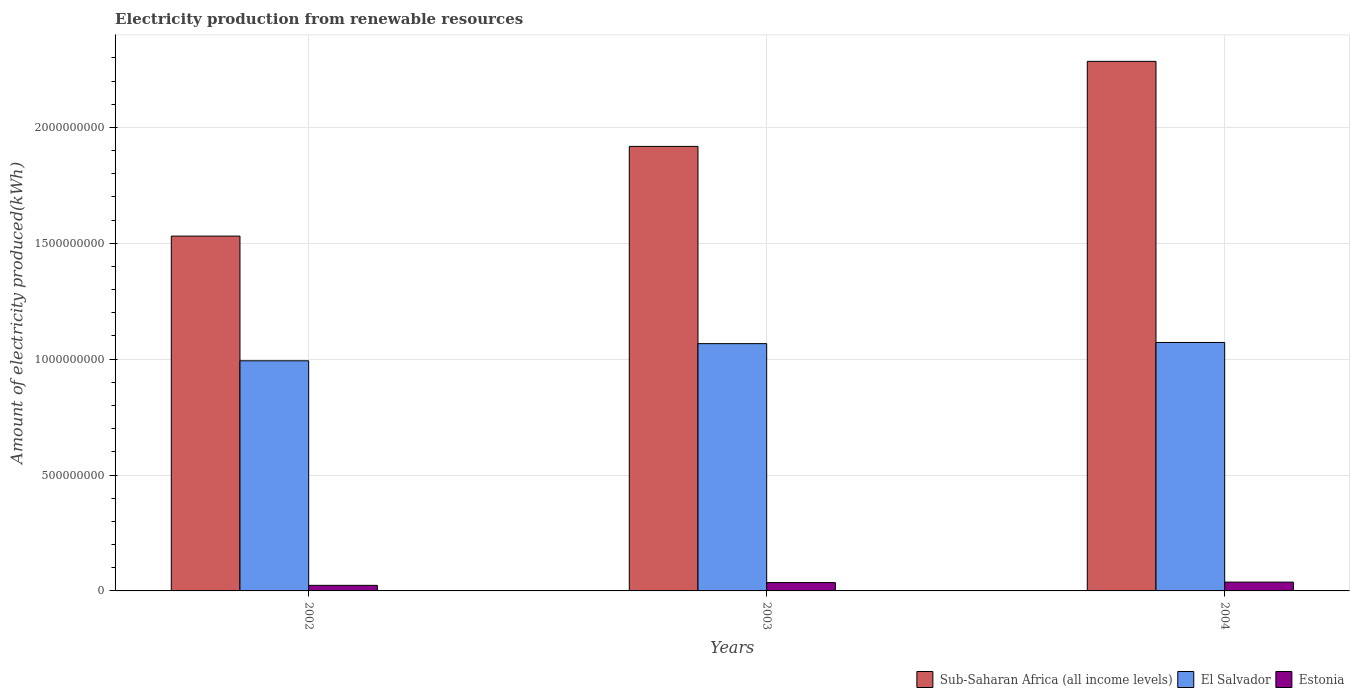How many different coloured bars are there?
Your answer should be compact. 3. Are the number of bars on each tick of the X-axis equal?
Your response must be concise. Yes. How many bars are there on the 1st tick from the right?
Your answer should be compact. 3. In how many cases, is the number of bars for a given year not equal to the number of legend labels?
Offer a terse response. 0. What is the amount of electricity produced in Sub-Saharan Africa (all income levels) in 2002?
Make the answer very short. 1.53e+09. Across all years, what is the maximum amount of electricity produced in Estonia?
Offer a terse response. 3.80e+07. Across all years, what is the minimum amount of electricity produced in Sub-Saharan Africa (all income levels)?
Your response must be concise. 1.53e+09. In which year was the amount of electricity produced in Estonia maximum?
Your response must be concise. 2004. What is the total amount of electricity produced in Sub-Saharan Africa (all income levels) in the graph?
Give a very brief answer. 5.73e+09. What is the difference between the amount of electricity produced in Sub-Saharan Africa (all income levels) in 2003 and that in 2004?
Keep it short and to the point. -3.67e+08. What is the difference between the amount of electricity produced in Sub-Saharan Africa (all income levels) in 2003 and the amount of electricity produced in Estonia in 2002?
Your response must be concise. 1.89e+09. What is the average amount of electricity produced in Sub-Saharan Africa (all income levels) per year?
Your answer should be compact. 1.91e+09. In the year 2003, what is the difference between the amount of electricity produced in El Salvador and amount of electricity produced in Sub-Saharan Africa (all income levels)?
Offer a very short reply. -8.51e+08. In how many years, is the amount of electricity produced in Estonia greater than 2200000000 kWh?
Make the answer very short. 0. What is the ratio of the amount of electricity produced in Estonia in 2003 to that in 2004?
Your answer should be compact. 0.95. Is the amount of electricity produced in Sub-Saharan Africa (all income levels) in 2002 less than that in 2004?
Ensure brevity in your answer.  Yes. Is the difference between the amount of electricity produced in El Salvador in 2003 and 2004 greater than the difference between the amount of electricity produced in Sub-Saharan Africa (all income levels) in 2003 and 2004?
Make the answer very short. Yes. What is the difference between the highest and the second highest amount of electricity produced in El Salvador?
Give a very brief answer. 5.00e+06. What is the difference between the highest and the lowest amount of electricity produced in Sub-Saharan Africa (all income levels)?
Offer a terse response. 7.54e+08. In how many years, is the amount of electricity produced in Sub-Saharan Africa (all income levels) greater than the average amount of electricity produced in Sub-Saharan Africa (all income levels) taken over all years?
Your answer should be very brief. 2. Is the sum of the amount of electricity produced in Estonia in 2003 and 2004 greater than the maximum amount of electricity produced in El Salvador across all years?
Make the answer very short. No. What does the 3rd bar from the left in 2002 represents?
Make the answer very short. Estonia. What does the 3rd bar from the right in 2002 represents?
Provide a short and direct response. Sub-Saharan Africa (all income levels). Is it the case that in every year, the sum of the amount of electricity produced in El Salvador and amount of electricity produced in Estonia is greater than the amount of electricity produced in Sub-Saharan Africa (all income levels)?
Provide a short and direct response. No. How many years are there in the graph?
Keep it short and to the point. 3. What is the difference between two consecutive major ticks on the Y-axis?
Provide a short and direct response. 5.00e+08. Are the values on the major ticks of Y-axis written in scientific E-notation?
Provide a short and direct response. No. Does the graph contain any zero values?
Ensure brevity in your answer.  No. What is the title of the graph?
Provide a succinct answer. Electricity production from renewable resources. Does "Barbados" appear as one of the legend labels in the graph?
Keep it short and to the point. No. What is the label or title of the X-axis?
Provide a succinct answer. Years. What is the label or title of the Y-axis?
Give a very brief answer. Amount of electricity produced(kWh). What is the Amount of electricity produced(kWh) in Sub-Saharan Africa (all income levels) in 2002?
Make the answer very short. 1.53e+09. What is the Amount of electricity produced(kWh) in El Salvador in 2002?
Provide a succinct answer. 9.93e+08. What is the Amount of electricity produced(kWh) in Estonia in 2002?
Your answer should be very brief. 2.40e+07. What is the Amount of electricity produced(kWh) in Sub-Saharan Africa (all income levels) in 2003?
Offer a terse response. 1.92e+09. What is the Amount of electricity produced(kWh) in El Salvador in 2003?
Offer a terse response. 1.07e+09. What is the Amount of electricity produced(kWh) in Estonia in 2003?
Your answer should be very brief. 3.60e+07. What is the Amount of electricity produced(kWh) of Sub-Saharan Africa (all income levels) in 2004?
Provide a succinct answer. 2.28e+09. What is the Amount of electricity produced(kWh) in El Salvador in 2004?
Provide a short and direct response. 1.07e+09. What is the Amount of electricity produced(kWh) in Estonia in 2004?
Your response must be concise. 3.80e+07. Across all years, what is the maximum Amount of electricity produced(kWh) of Sub-Saharan Africa (all income levels)?
Keep it short and to the point. 2.28e+09. Across all years, what is the maximum Amount of electricity produced(kWh) of El Salvador?
Keep it short and to the point. 1.07e+09. Across all years, what is the maximum Amount of electricity produced(kWh) in Estonia?
Provide a succinct answer. 3.80e+07. Across all years, what is the minimum Amount of electricity produced(kWh) in Sub-Saharan Africa (all income levels)?
Your response must be concise. 1.53e+09. Across all years, what is the minimum Amount of electricity produced(kWh) in El Salvador?
Give a very brief answer. 9.93e+08. Across all years, what is the minimum Amount of electricity produced(kWh) in Estonia?
Your answer should be compact. 2.40e+07. What is the total Amount of electricity produced(kWh) in Sub-Saharan Africa (all income levels) in the graph?
Give a very brief answer. 5.73e+09. What is the total Amount of electricity produced(kWh) of El Salvador in the graph?
Make the answer very short. 3.13e+09. What is the total Amount of electricity produced(kWh) in Estonia in the graph?
Your answer should be very brief. 9.80e+07. What is the difference between the Amount of electricity produced(kWh) of Sub-Saharan Africa (all income levels) in 2002 and that in 2003?
Keep it short and to the point. -3.87e+08. What is the difference between the Amount of electricity produced(kWh) of El Salvador in 2002 and that in 2003?
Offer a very short reply. -7.40e+07. What is the difference between the Amount of electricity produced(kWh) of Estonia in 2002 and that in 2003?
Your answer should be compact. -1.20e+07. What is the difference between the Amount of electricity produced(kWh) of Sub-Saharan Africa (all income levels) in 2002 and that in 2004?
Provide a succinct answer. -7.54e+08. What is the difference between the Amount of electricity produced(kWh) in El Salvador in 2002 and that in 2004?
Offer a terse response. -7.90e+07. What is the difference between the Amount of electricity produced(kWh) in Estonia in 2002 and that in 2004?
Your answer should be very brief. -1.40e+07. What is the difference between the Amount of electricity produced(kWh) of Sub-Saharan Africa (all income levels) in 2003 and that in 2004?
Provide a succinct answer. -3.67e+08. What is the difference between the Amount of electricity produced(kWh) of El Salvador in 2003 and that in 2004?
Offer a terse response. -5.00e+06. What is the difference between the Amount of electricity produced(kWh) in Sub-Saharan Africa (all income levels) in 2002 and the Amount of electricity produced(kWh) in El Salvador in 2003?
Your response must be concise. 4.64e+08. What is the difference between the Amount of electricity produced(kWh) of Sub-Saharan Africa (all income levels) in 2002 and the Amount of electricity produced(kWh) of Estonia in 2003?
Give a very brief answer. 1.50e+09. What is the difference between the Amount of electricity produced(kWh) of El Salvador in 2002 and the Amount of electricity produced(kWh) of Estonia in 2003?
Your answer should be compact. 9.57e+08. What is the difference between the Amount of electricity produced(kWh) of Sub-Saharan Africa (all income levels) in 2002 and the Amount of electricity produced(kWh) of El Salvador in 2004?
Make the answer very short. 4.59e+08. What is the difference between the Amount of electricity produced(kWh) of Sub-Saharan Africa (all income levels) in 2002 and the Amount of electricity produced(kWh) of Estonia in 2004?
Keep it short and to the point. 1.49e+09. What is the difference between the Amount of electricity produced(kWh) in El Salvador in 2002 and the Amount of electricity produced(kWh) in Estonia in 2004?
Offer a terse response. 9.55e+08. What is the difference between the Amount of electricity produced(kWh) of Sub-Saharan Africa (all income levels) in 2003 and the Amount of electricity produced(kWh) of El Salvador in 2004?
Provide a short and direct response. 8.46e+08. What is the difference between the Amount of electricity produced(kWh) of Sub-Saharan Africa (all income levels) in 2003 and the Amount of electricity produced(kWh) of Estonia in 2004?
Your answer should be very brief. 1.88e+09. What is the difference between the Amount of electricity produced(kWh) of El Salvador in 2003 and the Amount of electricity produced(kWh) of Estonia in 2004?
Your answer should be compact. 1.03e+09. What is the average Amount of electricity produced(kWh) in Sub-Saharan Africa (all income levels) per year?
Provide a short and direct response. 1.91e+09. What is the average Amount of electricity produced(kWh) in El Salvador per year?
Provide a short and direct response. 1.04e+09. What is the average Amount of electricity produced(kWh) in Estonia per year?
Offer a very short reply. 3.27e+07. In the year 2002, what is the difference between the Amount of electricity produced(kWh) of Sub-Saharan Africa (all income levels) and Amount of electricity produced(kWh) of El Salvador?
Your answer should be compact. 5.38e+08. In the year 2002, what is the difference between the Amount of electricity produced(kWh) in Sub-Saharan Africa (all income levels) and Amount of electricity produced(kWh) in Estonia?
Offer a very short reply. 1.51e+09. In the year 2002, what is the difference between the Amount of electricity produced(kWh) of El Salvador and Amount of electricity produced(kWh) of Estonia?
Keep it short and to the point. 9.69e+08. In the year 2003, what is the difference between the Amount of electricity produced(kWh) in Sub-Saharan Africa (all income levels) and Amount of electricity produced(kWh) in El Salvador?
Your answer should be compact. 8.51e+08. In the year 2003, what is the difference between the Amount of electricity produced(kWh) in Sub-Saharan Africa (all income levels) and Amount of electricity produced(kWh) in Estonia?
Give a very brief answer. 1.88e+09. In the year 2003, what is the difference between the Amount of electricity produced(kWh) in El Salvador and Amount of electricity produced(kWh) in Estonia?
Your answer should be compact. 1.03e+09. In the year 2004, what is the difference between the Amount of electricity produced(kWh) of Sub-Saharan Africa (all income levels) and Amount of electricity produced(kWh) of El Salvador?
Your answer should be very brief. 1.21e+09. In the year 2004, what is the difference between the Amount of electricity produced(kWh) of Sub-Saharan Africa (all income levels) and Amount of electricity produced(kWh) of Estonia?
Provide a short and direct response. 2.25e+09. In the year 2004, what is the difference between the Amount of electricity produced(kWh) of El Salvador and Amount of electricity produced(kWh) of Estonia?
Provide a short and direct response. 1.03e+09. What is the ratio of the Amount of electricity produced(kWh) of Sub-Saharan Africa (all income levels) in 2002 to that in 2003?
Provide a succinct answer. 0.8. What is the ratio of the Amount of electricity produced(kWh) of El Salvador in 2002 to that in 2003?
Your answer should be very brief. 0.93. What is the ratio of the Amount of electricity produced(kWh) of Estonia in 2002 to that in 2003?
Offer a terse response. 0.67. What is the ratio of the Amount of electricity produced(kWh) in Sub-Saharan Africa (all income levels) in 2002 to that in 2004?
Give a very brief answer. 0.67. What is the ratio of the Amount of electricity produced(kWh) in El Salvador in 2002 to that in 2004?
Provide a succinct answer. 0.93. What is the ratio of the Amount of electricity produced(kWh) of Estonia in 2002 to that in 2004?
Your answer should be very brief. 0.63. What is the ratio of the Amount of electricity produced(kWh) in Sub-Saharan Africa (all income levels) in 2003 to that in 2004?
Offer a very short reply. 0.84. What is the difference between the highest and the second highest Amount of electricity produced(kWh) of Sub-Saharan Africa (all income levels)?
Your response must be concise. 3.67e+08. What is the difference between the highest and the second highest Amount of electricity produced(kWh) of Estonia?
Keep it short and to the point. 2.00e+06. What is the difference between the highest and the lowest Amount of electricity produced(kWh) in Sub-Saharan Africa (all income levels)?
Your answer should be compact. 7.54e+08. What is the difference between the highest and the lowest Amount of electricity produced(kWh) in El Salvador?
Offer a terse response. 7.90e+07. What is the difference between the highest and the lowest Amount of electricity produced(kWh) of Estonia?
Your response must be concise. 1.40e+07. 